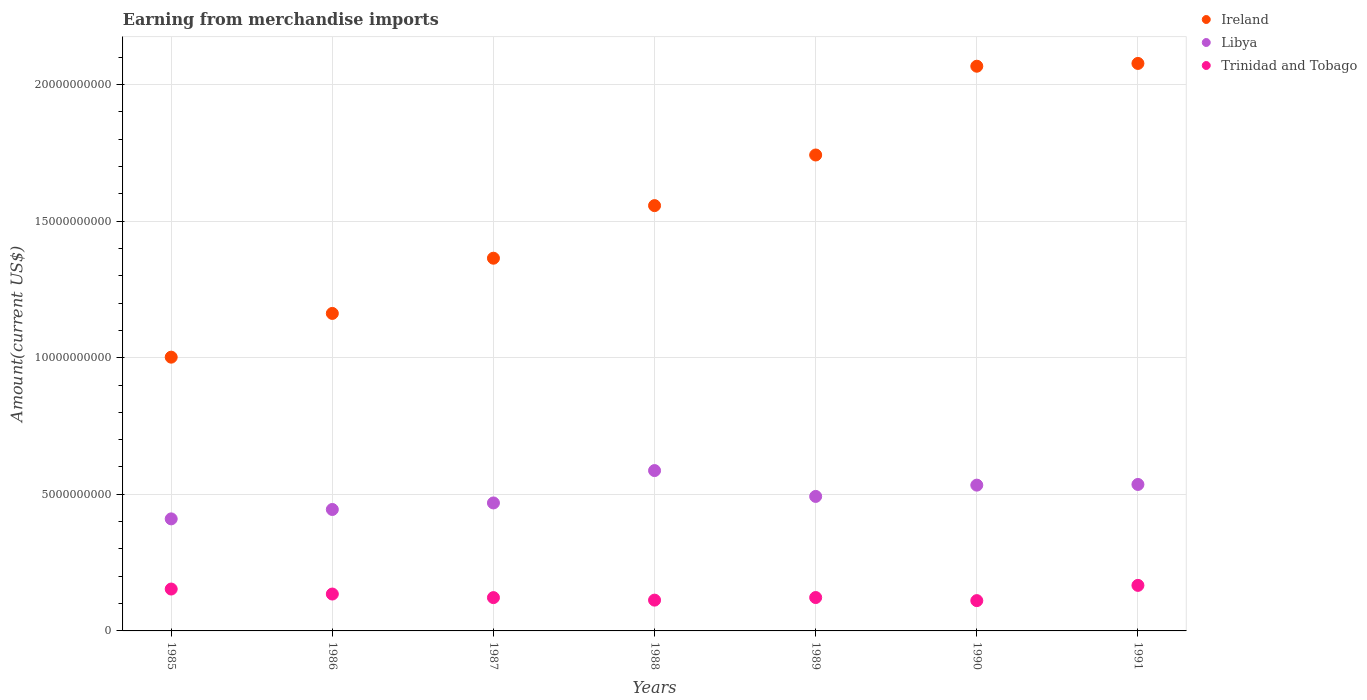How many different coloured dotlines are there?
Provide a succinct answer. 3. What is the amount earned from merchandise imports in Libya in 1985?
Your answer should be very brief. 4.10e+09. Across all years, what is the maximum amount earned from merchandise imports in Ireland?
Give a very brief answer. 2.08e+1. Across all years, what is the minimum amount earned from merchandise imports in Libya?
Make the answer very short. 4.10e+09. In which year was the amount earned from merchandise imports in Libya minimum?
Your answer should be compact. 1985. What is the total amount earned from merchandise imports in Trinidad and Tobago in the graph?
Your response must be concise. 9.23e+09. What is the difference between the amount earned from merchandise imports in Trinidad and Tobago in 1987 and that in 1988?
Make the answer very short. 9.20e+07. What is the difference between the amount earned from merchandise imports in Ireland in 1991 and the amount earned from merchandise imports in Libya in 1990?
Offer a terse response. 1.54e+1. What is the average amount earned from merchandise imports in Libya per year?
Make the answer very short. 4.96e+09. In the year 1985, what is the difference between the amount earned from merchandise imports in Libya and amount earned from merchandise imports in Ireland?
Give a very brief answer. -5.92e+09. In how many years, is the amount earned from merchandise imports in Trinidad and Tobago greater than 2000000000 US$?
Your response must be concise. 0. What is the ratio of the amount earned from merchandise imports in Libya in 1985 to that in 1991?
Your answer should be compact. 0.76. What is the difference between the highest and the second highest amount earned from merchandise imports in Libya?
Provide a short and direct response. 5.08e+08. What is the difference between the highest and the lowest amount earned from merchandise imports in Ireland?
Your response must be concise. 1.08e+1. Is it the case that in every year, the sum of the amount earned from merchandise imports in Libya and amount earned from merchandise imports in Trinidad and Tobago  is greater than the amount earned from merchandise imports in Ireland?
Make the answer very short. No. Is the amount earned from merchandise imports in Trinidad and Tobago strictly greater than the amount earned from merchandise imports in Libya over the years?
Provide a short and direct response. No. How many dotlines are there?
Make the answer very short. 3. What is the difference between two consecutive major ticks on the Y-axis?
Your answer should be very brief. 5.00e+09. Does the graph contain any zero values?
Ensure brevity in your answer.  No. Does the graph contain grids?
Ensure brevity in your answer.  Yes. How many legend labels are there?
Your answer should be compact. 3. What is the title of the graph?
Provide a succinct answer. Earning from merchandise imports. Does "Costa Rica" appear as one of the legend labels in the graph?
Offer a very short reply. No. What is the label or title of the Y-axis?
Keep it short and to the point. Amount(current US$). What is the Amount(current US$) of Ireland in 1985?
Give a very brief answer. 1.00e+1. What is the Amount(current US$) in Libya in 1985?
Your answer should be compact. 4.10e+09. What is the Amount(current US$) of Trinidad and Tobago in 1985?
Your answer should be very brief. 1.53e+09. What is the Amount(current US$) of Ireland in 1986?
Ensure brevity in your answer.  1.16e+1. What is the Amount(current US$) in Libya in 1986?
Keep it short and to the point. 4.44e+09. What is the Amount(current US$) of Trinidad and Tobago in 1986?
Provide a short and direct response. 1.35e+09. What is the Amount(current US$) of Ireland in 1987?
Make the answer very short. 1.36e+1. What is the Amount(current US$) in Libya in 1987?
Ensure brevity in your answer.  4.68e+09. What is the Amount(current US$) of Trinidad and Tobago in 1987?
Offer a very short reply. 1.22e+09. What is the Amount(current US$) in Ireland in 1988?
Your answer should be very brief. 1.56e+1. What is the Amount(current US$) in Libya in 1988?
Provide a short and direct response. 5.87e+09. What is the Amount(current US$) in Trinidad and Tobago in 1988?
Provide a succinct answer. 1.13e+09. What is the Amount(current US$) of Ireland in 1989?
Make the answer very short. 1.74e+1. What is the Amount(current US$) in Libya in 1989?
Your response must be concise. 4.92e+09. What is the Amount(current US$) of Trinidad and Tobago in 1989?
Provide a succinct answer. 1.22e+09. What is the Amount(current US$) in Ireland in 1990?
Give a very brief answer. 2.07e+1. What is the Amount(current US$) of Libya in 1990?
Your answer should be very brief. 5.34e+09. What is the Amount(current US$) in Trinidad and Tobago in 1990?
Offer a terse response. 1.11e+09. What is the Amount(current US$) of Ireland in 1991?
Make the answer very short. 2.08e+1. What is the Amount(current US$) in Libya in 1991?
Provide a short and direct response. 5.36e+09. What is the Amount(current US$) in Trinidad and Tobago in 1991?
Make the answer very short. 1.67e+09. Across all years, what is the maximum Amount(current US$) of Ireland?
Keep it short and to the point. 2.08e+1. Across all years, what is the maximum Amount(current US$) of Libya?
Ensure brevity in your answer.  5.87e+09. Across all years, what is the maximum Amount(current US$) in Trinidad and Tobago?
Offer a terse response. 1.67e+09. Across all years, what is the minimum Amount(current US$) of Ireland?
Your answer should be compact. 1.00e+1. Across all years, what is the minimum Amount(current US$) of Libya?
Give a very brief answer. 4.10e+09. Across all years, what is the minimum Amount(current US$) of Trinidad and Tobago?
Your answer should be compact. 1.11e+09. What is the total Amount(current US$) in Ireland in the graph?
Provide a succinct answer. 1.10e+11. What is the total Amount(current US$) of Libya in the graph?
Make the answer very short. 3.47e+1. What is the total Amount(current US$) in Trinidad and Tobago in the graph?
Give a very brief answer. 9.23e+09. What is the difference between the Amount(current US$) of Ireland in 1985 and that in 1986?
Provide a short and direct response. -1.60e+09. What is the difference between the Amount(current US$) in Libya in 1985 and that in 1986?
Provide a succinct answer. -3.44e+08. What is the difference between the Amount(current US$) in Trinidad and Tobago in 1985 and that in 1986?
Keep it short and to the point. 1.83e+08. What is the difference between the Amount(current US$) in Ireland in 1985 and that in 1987?
Give a very brief answer. -3.62e+09. What is the difference between the Amount(current US$) in Libya in 1985 and that in 1987?
Provide a short and direct response. -5.83e+08. What is the difference between the Amount(current US$) in Trinidad and Tobago in 1985 and that in 1987?
Your answer should be compact. 3.14e+08. What is the difference between the Amount(current US$) in Ireland in 1985 and that in 1988?
Provide a succinct answer. -5.55e+09. What is the difference between the Amount(current US$) of Libya in 1985 and that in 1988?
Give a very brief answer. -1.77e+09. What is the difference between the Amount(current US$) of Trinidad and Tobago in 1985 and that in 1988?
Make the answer very short. 4.06e+08. What is the difference between the Amount(current US$) in Ireland in 1985 and that in 1989?
Your answer should be very brief. -7.40e+09. What is the difference between the Amount(current US$) of Libya in 1985 and that in 1989?
Offer a terse response. -8.22e+08. What is the difference between the Amount(current US$) of Trinidad and Tobago in 1985 and that in 1989?
Provide a succinct answer. 3.11e+08. What is the difference between the Amount(current US$) of Ireland in 1985 and that in 1990?
Your answer should be compact. -1.06e+1. What is the difference between the Amount(current US$) of Libya in 1985 and that in 1990?
Keep it short and to the point. -1.24e+09. What is the difference between the Amount(current US$) of Trinidad and Tobago in 1985 and that in 1990?
Your answer should be compact. 4.24e+08. What is the difference between the Amount(current US$) of Ireland in 1985 and that in 1991?
Your answer should be very brief. -1.08e+1. What is the difference between the Amount(current US$) of Libya in 1985 and that in 1991?
Make the answer very short. -1.26e+09. What is the difference between the Amount(current US$) in Trinidad and Tobago in 1985 and that in 1991?
Provide a short and direct response. -1.34e+08. What is the difference between the Amount(current US$) in Ireland in 1986 and that in 1987?
Your answer should be very brief. -2.02e+09. What is the difference between the Amount(current US$) in Libya in 1986 and that in 1987?
Offer a terse response. -2.39e+08. What is the difference between the Amount(current US$) of Trinidad and Tobago in 1986 and that in 1987?
Give a very brief answer. 1.31e+08. What is the difference between the Amount(current US$) of Ireland in 1986 and that in 1988?
Provide a short and direct response. -3.95e+09. What is the difference between the Amount(current US$) in Libya in 1986 and that in 1988?
Your answer should be very brief. -1.42e+09. What is the difference between the Amount(current US$) in Trinidad and Tobago in 1986 and that in 1988?
Provide a succinct answer. 2.23e+08. What is the difference between the Amount(current US$) of Ireland in 1986 and that in 1989?
Offer a terse response. -5.80e+09. What is the difference between the Amount(current US$) of Libya in 1986 and that in 1989?
Keep it short and to the point. -4.78e+08. What is the difference between the Amount(current US$) of Trinidad and Tobago in 1986 and that in 1989?
Offer a terse response. 1.28e+08. What is the difference between the Amount(current US$) of Ireland in 1986 and that in 1990?
Provide a short and direct response. -9.05e+09. What is the difference between the Amount(current US$) in Libya in 1986 and that in 1990?
Your answer should be very brief. -8.91e+08. What is the difference between the Amount(current US$) of Trinidad and Tobago in 1986 and that in 1990?
Your answer should be compact. 2.41e+08. What is the difference between the Amount(current US$) in Ireland in 1986 and that in 1991?
Give a very brief answer. -9.15e+09. What is the difference between the Amount(current US$) in Libya in 1986 and that in 1991?
Your answer should be very brief. -9.16e+08. What is the difference between the Amount(current US$) of Trinidad and Tobago in 1986 and that in 1991?
Keep it short and to the point. -3.17e+08. What is the difference between the Amount(current US$) in Ireland in 1987 and that in 1988?
Your response must be concise. -1.92e+09. What is the difference between the Amount(current US$) of Libya in 1987 and that in 1988?
Provide a short and direct response. -1.18e+09. What is the difference between the Amount(current US$) in Trinidad and Tobago in 1987 and that in 1988?
Make the answer very short. 9.20e+07. What is the difference between the Amount(current US$) in Ireland in 1987 and that in 1989?
Ensure brevity in your answer.  -3.78e+09. What is the difference between the Amount(current US$) of Libya in 1987 and that in 1989?
Offer a very short reply. -2.39e+08. What is the difference between the Amount(current US$) of Trinidad and Tobago in 1987 and that in 1989?
Your answer should be compact. -3.00e+06. What is the difference between the Amount(current US$) in Ireland in 1987 and that in 1990?
Your response must be concise. -7.03e+09. What is the difference between the Amount(current US$) in Libya in 1987 and that in 1990?
Your response must be concise. -6.52e+08. What is the difference between the Amount(current US$) of Trinidad and Tobago in 1987 and that in 1990?
Offer a terse response. 1.10e+08. What is the difference between the Amount(current US$) in Ireland in 1987 and that in 1991?
Give a very brief answer. -7.13e+09. What is the difference between the Amount(current US$) in Libya in 1987 and that in 1991?
Offer a terse response. -6.77e+08. What is the difference between the Amount(current US$) in Trinidad and Tobago in 1987 and that in 1991?
Offer a very short reply. -4.48e+08. What is the difference between the Amount(current US$) in Ireland in 1988 and that in 1989?
Make the answer very short. -1.85e+09. What is the difference between the Amount(current US$) of Libya in 1988 and that in 1989?
Provide a succinct answer. 9.46e+08. What is the difference between the Amount(current US$) of Trinidad and Tobago in 1988 and that in 1989?
Provide a short and direct response. -9.50e+07. What is the difference between the Amount(current US$) of Ireland in 1988 and that in 1990?
Provide a succinct answer. -5.10e+09. What is the difference between the Amount(current US$) in Libya in 1988 and that in 1990?
Your answer should be very brief. 5.33e+08. What is the difference between the Amount(current US$) of Trinidad and Tobago in 1988 and that in 1990?
Offer a terse response. 1.80e+07. What is the difference between the Amount(current US$) in Ireland in 1988 and that in 1991?
Your answer should be very brief. -5.20e+09. What is the difference between the Amount(current US$) in Libya in 1988 and that in 1991?
Your answer should be very brief. 5.08e+08. What is the difference between the Amount(current US$) of Trinidad and Tobago in 1988 and that in 1991?
Ensure brevity in your answer.  -5.40e+08. What is the difference between the Amount(current US$) in Ireland in 1989 and that in 1990?
Your answer should be compact. -3.25e+09. What is the difference between the Amount(current US$) of Libya in 1989 and that in 1990?
Offer a terse response. -4.13e+08. What is the difference between the Amount(current US$) in Trinidad and Tobago in 1989 and that in 1990?
Make the answer very short. 1.13e+08. What is the difference between the Amount(current US$) of Ireland in 1989 and that in 1991?
Offer a very short reply. -3.35e+09. What is the difference between the Amount(current US$) of Libya in 1989 and that in 1991?
Make the answer very short. -4.38e+08. What is the difference between the Amount(current US$) of Trinidad and Tobago in 1989 and that in 1991?
Provide a short and direct response. -4.45e+08. What is the difference between the Amount(current US$) in Ireland in 1990 and that in 1991?
Your answer should be compact. -1.02e+08. What is the difference between the Amount(current US$) of Libya in 1990 and that in 1991?
Keep it short and to the point. -2.50e+07. What is the difference between the Amount(current US$) of Trinidad and Tobago in 1990 and that in 1991?
Make the answer very short. -5.58e+08. What is the difference between the Amount(current US$) in Ireland in 1985 and the Amount(current US$) in Libya in 1986?
Give a very brief answer. 5.58e+09. What is the difference between the Amount(current US$) of Ireland in 1985 and the Amount(current US$) of Trinidad and Tobago in 1986?
Ensure brevity in your answer.  8.67e+09. What is the difference between the Amount(current US$) in Libya in 1985 and the Amount(current US$) in Trinidad and Tobago in 1986?
Offer a very short reply. 2.75e+09. What is the difference between the Amount(current US$) of Ireland in 1985 and the Amount(current US$) of Libya in 1987?
Give a very brief answer. 5.34e+09. What is the difference between the Amount(current US$) in Ireland in 1985 and the Amount(current US$) in Trinidad and Tobago in 1987?
Keep it short and to the point. 8.80e+09. What is the difference between the Amount(current US$) in Libya in 1985 and the Amount(current US$) in Trinidad and Tobago in 1987?
Ensure brevity in your answer.  2.88e+09. What is the difference between the Amount(current US$) in Ireland in 1985 and the Amount(current US$) in Libya in 1988?
Provide a succinct answer. 4.15e+09. What is the difference between the Amount(current US$) of Ireland in 1985 and the Amount(current US$) of Trinidad and Tobago in 1988?
Keep it short and to the point. 8.89e+09. What is the difference between the Amount(current US$) in Libya in 1985 and the Amount(current US$) in Trinidad and Tobago in 1988?
Your answer should be very brief. 2.97e+09. What is the difference between the Amount(current US$) of Ireland in 1985 and the Amount(current US$) of Libya in 1989?
Provide a succinct answer. 5.10e+09. What is the difference between the Amount(current US$) of Ireland in 1985 and the Amount(current US$) of Trinidad and Tobago in 1989?
Your answer should be very brief. 8.80e+09. What is the difference between the Amount(current US$) of Libya in 1985 and the Amount(current US$) of Trinidad and Tobago in 1989?
Your answer should be compact. 2.88e+09. What is the difference between the Amount(current US$) of Ireland in 1985 and the Amount(current US$) of Libya in 1990?
Ensure brevity in your answer.  4.68e+09. What is the difference between the Amount(current US$) in Ireland in 1985 and the Amount(current US$) in Trinidad and Tobago in 1990?
Keep it short and to the point. 8.91e+09. What is the difference between the Amount(current US$) in Libya in 1985 and the Amount(current US$) in Trinidad and Tobago in 1990?
Keep it short and to the point. 2.99e+09. What is the difference between the Amount(current US$) in Ireland in 1985 and the Amount(current US$) in Libya in 1991?
Offer a terse response. 4.66e+09. What is the difference between the Amount(current US$) of Ireland in 1985 and the Amount(current US$) of Trinidad and Tobago in 1991?
Your answer should be compact. 8.35e+09. What is the difference between the Amount(current US$) of Libya in 1985 and the Amount(current US$) of Trinidad and Tobago in 1991?
Give a very brief answer. 2.43e+09. What is the difference between the Amount(current US$) of Ireland in 1986 and the Amount(current US$) of Libya in 1987?
Provide a short and direct response. 6.94e+09. What is the difference between the Amount(current US$) of Ireland in 1986 and the Amount(current US$) of Trinidad and Tobago in 1987?
Your answer should be very brief. 1.04e+1. What is the difference between the Amount(current US$) of Libya in 1986 and the Amount(current US$) of Trinidad and Tobago in 1987?
Offer a very short reply. 3.23e+09. What is the difference between the Amount(current US$) in Ireland in 1986 and the Amount(current US$) in Libya in 1988?
Offer a very short reply. 5.75e+09. What is the difference between the Amount(current US$) of Ireland in 1986 and the Amount(current US$) of Trinidad and Tobago in 1988?
Offer a terse response. 1.05e+1. What is the difference between the Amount(current US$) in Libya in 1986 and the Amount(current US$) in Trinidad and Tobago in 1988?
Keep it short and to the point. 3.32e+09. What is the difference between the Amount(current US$) of Ireland in 1986 and the Amount(current US$) of Libya in 1989?
Offer a very short reply. 6.70e+09. What is the difference between the Amount(current US$) in Ireland in 1986 and the Amount(current US$) in Trinidad and Tobago in 1989?
Make the answer very short. 1.04e+1. What is the difference between the Amount(current US$) of Libya in 1986 and the Amount(current US$) of Trinidad and Tobago in 1989?
Provide a short and direct response. 3.22e+09. What is the difference between the Amount(current US$) of Ireland in 1986 and the Amount(current US$) of Libya in 1990?
Ensure brevity in your answer.  6.28e+09. What is the difference between the Amount(current US$) of Ireland in 1986 and the Amount(current US$) of Trinidad and Tobago in 1990?
Offer a terse response. 1.05e+1. What is the difference between the Amount(current US$) in Libya in 1986 and the Amount(current US$) in Trinidad and Tobago in 1990?
Make the answer very short. 3.34e+09. What is the difference between the Amount(current US$) of Ireland in 1986 and the Amount(current US$) of Libya in 1991?
Ensure brevity in your answer.  6.26e+09. What is the difference between the Amount(current US$) of Ireland in 1986 and the Amount(current US$) of Trinidad and Tobago in 1991?
Provide a succinct answer. 9.95e+09. What is the difference between the Amount(current US$) of Libya in 1986 and the Amount(current US$) of Trinidad and Tobago in 1991?
Your response must be concise. 2.78e+09. What is the difference between the Amount(current US$) of Ireland in 1987 and the Amount(current US$) of Libya in 1988?
Ensure brevity in your answer.  7.77e+09. What is the difference between the Amount(current US$) in Ireland in 1987 and the Amount(current US$) in Trinidad and Tobago in 1988?
Give a very brief answer. 1.25e+1. What is the difference between the Amount(current US$) of Libya in 1987 and the Amount(current US$) of Trinidad and Tobago in 1988?
Your response must be concise. 3.56e+09. What is the difference between the Amount(current US$) of Ireland in 1987 and the Amount(current US$) of Libya in 1989?
Provide a short and direct response. 8.72e+09. What is the difference between the Amount(current US$) in Ireland in 1987 and the Amount(current US$) in Trinidad and Tobago in 1989?
Offer a very short reply. 1.24e+1. What is the difference between the Amount(current US$) in Libya in 1987 and the Amount(current US$) in Trinidad and Tobago in 1989?
Ensure brevity in your answer.  3.46e+09. What is the difference between the Amount(current US$) in Ireland in 1987 and the Amount(current US$) in Libya in 1990?
Your response must be concise. 8.31e+09. What is the difference between the Amount(current US$) in Ireland in 1987 and the Amount(current US$) in Trinidad and Tobago in 1990?
Your answer should be very brief. 1.25e+1. What is the difference between the Amount(current US$) in Libya in 1987 and the Amount(current US$) in Trinidad and Tobago in 1990?
Keep it short and to the point. 3.58e+09. What is the difference between the Amount(current US$) in Ireland in 1987 and the Amount(current US$) in Libya in 1991?
Ensure brevity in your answer.  8.28e+09. What is the difference between the Amount(current US$) of Ireland in 1987 and the Amount(current US$) of Trinidad and Tobago in 1991?
Give a very brief answer. 1.20e+1. What is the difference between the Amount(current US$) in Libya in 1987 and the Amount(current US$) in Trinidad and Tobago in 1991?
Give a very brief answer. 3.02e+09. What is the difference between the Amount(current US$) in Ireland in 1988 and the Amount(current US$) in Libya in 1989?
Give a very brief answer. 1.06e+1. What is the difference between the Amount(current US$) in Ireland in 1988 and the Amount(current US$) in Trinidad and Tobago in 1989?
Ensure brevity in your answer.  1.43e+1. What is the difference between the Amount(current US$) of Libya in 1988 and the Amount(current US$) of Trinidad and Tobago in 1989?
Provide a succinct answer. 4.65e+09. What is the difference between the Amount(current US$) of Ireland in 1988 and the Amount(current US$) of Libya in 1990?
Keep it short and to the point. 1.02e+1. What is the difference between the Amount(current US$) of Ireland in 1988 and the Amount(current US$) of Trinidad and Tobago in 1990?
Provide a short and direct response. 1.45e+1. What is the difference between the Amount(current US$) of Libya in 1988 and the Amount(current US$) of Trinidad and Tobago in 1990?
Give a very brief answer. 4.76e+09. What is the difference between the Amount(current US$) in Ireland in 1988 and the Amount(current US$) in Libya in 1991?
Keep it short and to the point. 1.02e+1. What is the difference between the Amount(current US$) of Ireland in 1988 and the Amount(current US$) of Trinidad and Tobago in 1991?
Your response must be concise. 1.39e+1. What is the difference between the Amount(current US$) in Libya in 1988 and the Amount(current US$) in Trinidad and Tobago in 1991?
Ensure brevity in your answer.  4.20e+09. What is the difference between the Amount(current US$) of Ireland in 1989 and the Amount(current US$) of Libya in 1990?
Ensure brevity in your answer.  1.21e+1. What is the difference between the Amount(current US$) of Ireland in 1989 and the Amount(current US$) of Trinidad and Tobago in 1990?
Offer a terse response. 1.63e+1. What is the difference between the Amount(current US$) in Libya in 1989 and the Amount(current US$) in Trinidad and Tobago in 1990?
Give a very brief answer. 3.81e+09. What is the difference between the Amount(current US$) in Ireland in 1989 and the Amount(current US$) in Libya in 1991?
Give a very brief answer. 1.21e+1. What is the difference between the Amount(current US$) in Ireland in 1989 and the Amount(current US$) in Trinidad and Tobago in 1991?
Ensure brevity in your answer.  1.58e+1. What is the difference between the Amount(current US$) of Libya in 1989 and the Amount(current US$) of Trinidad and Tobago in 1991?
Give a very brief answer. 3.26e+09. What is the difference between the Amount(current US$) in Ireland in 1990 and the Amount(current US$) in Libya in 1991?
Offer a terse response. 1.53e+1. What is the difference between the Amount(current US$) in Ireland in 1990 and the Amount(current US$) in Trinidad and Tobago in 1991?
Offer a very short reply. 1.90e+1. What is the difference between the Amount(current US$) in Libya in 1990 and the Amount(current US$) in Trinidad and Tobago in 1991?
Offer a very short reply. 3.67e+09. What is the average Amount(current US$) of Ireland per year?
Your answer should be compact. 1.57e+1. What is the average Amount(current US$) of Libya per year?
Ensure brevity in your answer.  4.96e+09. What is the average Amount(current US$) of Trinidad and Tobago per year?
Keep it short and to the point. 1.32e+09. In the year 1985, what is the difference between the Amount(current US$) in Ireland and Amount(current US$) in Libya?
Give a very brief answer. 5.92e+09. In the year 1985, what is the difference between the Amount(current US$) in Ireland and Amount(current US$) in Trinidad and Tobago?
Provide a short and direct response. 8.49e+09. In the year 1985, what is the difference between the Amount(current US$) in Libya and Amount(current US$) in Trinidad and Tobago?
Keep it short and to the point. 2.57e+09. In the year 1986, what is the difference between the Amount(current US$) in Ireland and Amount(current US$) in Libya?
Offer a very short reply. 7.18e+09. In the year 1986, what is the difference between the Amount(current US$) in Ireland and Amount(current US$) in Trinidad and Tobago?
Provide a succinct answer. 1.03e+1. In the year 1986, what is the difference between the Amount(current US$) in Libya and Amount(current US$) in Trinidad and Tobago?
Your response must be concise. 3.10e+09. In the year 1987, what is the difference between the Amount(current US$) in Ireland and Amount(current US$) in Libya?
Your answer should be very brief. 8.96e+09. In the year 1987, what is the difference between the Amount(current US$) in Ireland and Amount(current US$) in Trinidad and Tobago?
Keep it short and to the point. 1.24e+1. In the year 1987, what is the difference between the Amount(current US$) of Libya and Amount(current US$) of Trinidad and Tobago?
Provide a succinct answer. 3.46e+09. In the year 1988, what is the difference between the Amount(current US$) in Ireland and Amount(current US$) in Libya?
Your answer should be very brief. 9.70e+09. In the year 1988, what is the difference between the Amount(current US$) of Ireland and Amount(current US$) of Trinidad and Tobago?
Your answer should be compact. 1.44e+1. In the year 1988, what is the difference between the Amount(current US$) of Libya and Amount(current US$) of Trinidad and Tobago?
Your answer should be compact. 4.74e+09. In the year 1989, what is the difference between the Amount(current US$) of Ireland and Amount(current US$) of Libya?
Offer a terse response. 1.25e+1. In the year 1989, what is the difference between the Amount(current US$) in Ireland and Amount(current US$) in Trinidad and Tobago?
Your response must be concise. 1.62e+1. In the year 1989, what is the difference between the Amount(current US$) of Libya and Amount(current US$) of Trinidad and Tobago?
Keep it short and to the point. 3.70e+09. In the year 1990, what is the difference between the Amount(current US$) in Ireland and Amount(current US$) in Libya?
Offer a very short reply. 1.53e+1. In the year 1990, what is the difference between the Amount(current US$) of Ireland and Amount(current US$) of Trinidad and Tobago?
Offer a terse response. 1.96e+1. In the year 1990, what is the difference between the Amount(current US$) of Libya and Amount(current US$) of Trinidad and Tobago?
Make the answer very short. 4.23e+09. In the year 1991, what is the difference between the Amount(current US$) in Ireland and Amount(current US$) in Libya?
Make the answer very short. 1.54e+1. In the year 1991, what is the difference between the Amount(current US$) in Ireland and Amount(current US$) in Trinidad and Tobago?
Your answer should be very brief. 1.91e+1. In the year 1991, what is the difference between the Amount(current US$) of Libya and Amount(current US$) of Trinidad and Tobago?
Your answer should be very brief. 3.69e+09. What is the ratio of the Amount(current US$) in Ireland in 1985 to that in 1986?
Keep it short and to the point. 0.86. What is the ratio of the Amount(current US$) of Libya in 1985 to that in 1986?
Your answer should be very brief. 0.92. What is the ratio of the Amount(current US$) of Trinidad and Tobago in 1985 to that in 1986?
Provide a short and direct response. 1.14. What is the ratio of the Amount(current US$) of Ireland in 1985 to that in 1987?
Give a very brief answer. 0.73. What is the ratio of the Amount(current US$) in Libya in 1985 to that in 1987?
Make the answer very short. 0.88. What is the ratio of the Amount(current US$) of Trinidad and Tobago in 1985 to that in 1987?
Make the answer very short. 1.26. What is the ratio of the Amount(current US$) of Ireland in 1985 to that in 1988?
Keep it short and to the point. 0.64. What is the ratio of the Amount(current US$) of Libya in 1985 to that in 1988?
Your answer should be very brief. 0.7. What is the ratio of the Amount(current US$) of Trinidad and Tobago in 1985 to that in 1988?
Provide a short and direct response. 1.36. What is the ratio of the Amount(current US$) in Ireland in 1985 to that in 1989?
Keep it short and to the point. 0.58. What is the ratio of the Amount(current US$) in Libya in 1985 to that in 1989?
Give a very brief answer. 0.83. What is the ratio of the Amount(current US$) of Trinidad and Tobago in 1985 to that in 1989?
Your answer should be very brief. 1.25. What is the ratio of the Amount(current US$) of Ireland in 1985 to that in 1990?
Your answer should be compact. 0.48. What is the ratio of the Amount(current US$) of Libya in 1985 to that in 1990?
Give a very brief answer. 0.77. What is the ratio of the Amount(current US$) of Trinidad and Tobago in 1985 to that in 1990?
Your answer should be very brief. 1.38. What is the ratio of the Amount(current US$) of Ireland in 1985 to that in 1991?
Give a very brief answer. 0.48. What is the ratio of the Amount(current US$) in Libya in 1985 to that in 1991?
Your answer should be very brief. 0.77. What is the ratio of the Amount(current US$) of Trinidad and Tobago in 1985 to that in 1991?
Make the answer very short. 0.92. What is the ratio of the Amount(current US$) in Ireland in 1986 to that in 1987?
Ensure brevity in your answer.  0.85. What is the ratio of the Amount(current US$) of Libya in 1986 to that in 1987?
Offer a terse response. 0.95. What is the ratio of the Amount(current US$) in Trinidad and Tobago in 1986 to that in 1987?
Your answer should be very brief. 1.11. What is the ratio of the Amount(current US$) in Ireland in 1986 to that in 1988?
Provide a short and direct response. 0.75. What is the ratio of the Amount(current US$) of Libya in 1986 to that in 1988?
Ensure brevity in your answer.  0.76. What is the ratio of the Amount(current US$) of Trinidad and Tobago in 1986 to that in 1988?
Offer a very short reply. 1.2. What is the ratio of the Amount(current US$) in Ireland in 1986 to that in 1989?
Provide a short and direct response. 0.67. What is the ratio of the Amount(current US$) in Libya in 1986 to that in 1989?
Provide a succinct answer. 0.9. What is the ratio of the Amount(current US$) in Trinidad and Tobago in 1986 to that in 1989?
Keep it short and to the point. 1.1. What is the ratio of the Amount(current US$) of Ireland in 1986 to that in 1990?
Keep it short and to the point. 0.56. What is the ratio of the Amount(current US$) in Libya in 1986 to that in 1990?
Make the answer very short. 0.83. What is the ratio of the Amount(current US$) in Trinidad and Tobago in 1986 to that in 1990?
Your answer should be compact. 1.22. What is the ratio of the Amount(current US$) of Ireland in 1986 to that in 1991?
Your answer should be very brief. 0.56. What is the ratio of the Amount(current US$) of Libya in 1986 to that in 1991?
Offer a terse response. 0.83. What is the ratio of the Amount(current US$) of Trinidad and Tobago in 1986 to that in 1991?
Offer a terse response. 0.81. What is the ratio of the Amount(current US$) of Ireland in 1987 to that in 1988?
Provide a succinct answer. 0.88. What is the ratio of the Amount(current US$) of Libya in 1987 to that in 1988?
Your response must be concise. 0.8. What is the ratio of the Amount(current US$) of Trinidad and Tobago in 1987 to that in 1988?
Make the answer very short. 1.08. What is the ratio of the Amount(current US$) of Ireland in 1987 to that in 1989?
Your answer should be very brief. 0.78. What is the ratio of the Amount(current US$) of Libya in 1987 to that in 1989?
Give a very brief answer. 0.95. What is the ratio of the Amount(current US$) in Ireland in 1987 to that in 1990?
Your answer should be compact. 0.66. What is the ratio of the Amount(current US$) in Libya in 1987 to that in 1990?
Your answer should be very brief. 0.88. What is the ratio of the Amount(current US$) in Trinidad and Tobago in 1987 to that in 1990?
Make the answer very short. 1.1. What is the ratio of the Amount(current US$) in Ireland in 1987 to that in 1991?
Your answer should be very brief. 0.66. What is the ratio of the Amount(current US$) in Libya in 1987 to that in 1991?
Your answer should be very brief. 0.87. What is the ratio of the Amount(current US$) of Trinidad and Tobago in 1987 to that in 1991?
Your response must be concise. 0.73. What is the ratio of the Amount(current US$) in Ireland in 1988 to that in 1989?
Keep it short and to the point. 0.89. What is the ratio of the Amount(current US$) of Libya in 1988 to that in 1989?
Give a very brief answer. 1.19. What is the ratio of the Amount(current US$) in Trinidad and Tobago in 1988 to that in 1989?
Provide a short and direct response. 0.92. What is the ratio of the Amount(current US$) of Ireland in 1988 to that in 1990?
Offer a terse response. 0.75. What is the ratio of the Amount(current US$) in Libya in 1988 to that in 1990?
Offer a very short reply. 1.1. What is the ratio of the Amount(current US$) in Trinidad and Tobago in 1988 to that in 1990?
Your response must be concise. 1.02. What is the ratio of the Amount(current US$) of Ireland in 1988 to that in 1991?
Make the answer very short. 0.75. What is the ratio of the Amount(current US$) in Libya in 1988 to that in 1991?
Your answer should be very brief. 1.09. What is the ratio of the Amount(current US$) of Trinidad and Tobago in 1988 to that in 1991?
Keep it short and to the point. 0.68. What is the ratio of the Amount(current US$) of Ireland in 1989 to that in 1990?
Ensure brevity in your answer.  0.84. What is the ratio of the Amount(current US$) of Libya in 1989 to that in 1990?
Your response must be concise. 0.92. What is the ratio of the Amount(current US$) in Trinidad and Tobago in 1989 to that in 1990?
Offer a terse response. 1.1. What is the ratio of the Amount(current US$) in Ireland in 1989 to that in 1991?
Your response must be concise. 0.84. What is the ratio of the Amount(current US$) of Libya in 1989 to that in 1991?
Provide a short and direct response. 0.92. What is the ratio of the Amount(current US$) in Trinidad and Tobago in 1989 to that in 1991?
Offer a terse response. 0.73. What is the ratio of the Amount(current US$) of Libya in 1990 to that in 1991?
Your answer should be compact. 1. What is the ratio of the Amount(current US$) of Trinidad and Tobago in 1990 to that in 1991?
Ensure brevity in your answer.  0.67. What is the difference between the highest and the second highest Amount(current US$) of Ireland?
Provide a succinct answer. 1.02e+08. What is the difference between the highest and the second highest Amount(current US$) of Libya?
Make the answer very short. 5.08e+08. What is the difference between the highest and the second highest Amount(current US$) in Trinidad and Tobago?
Keep it short and to the point. 1.34e+08. What is the difference between the highest and the lowest Amount(current US$) of Ireland?
Keep it short and to the point. 1.08e+1. What is the difference between the highest and the lowest Amount(current US$) in Libya?
Offer a very short reply. 1.77e+09. What is the difference between the highest and the lowest Amount(current US$) in Trinidad and Tobago?
Offer a very short reply. 5.58e+08. 